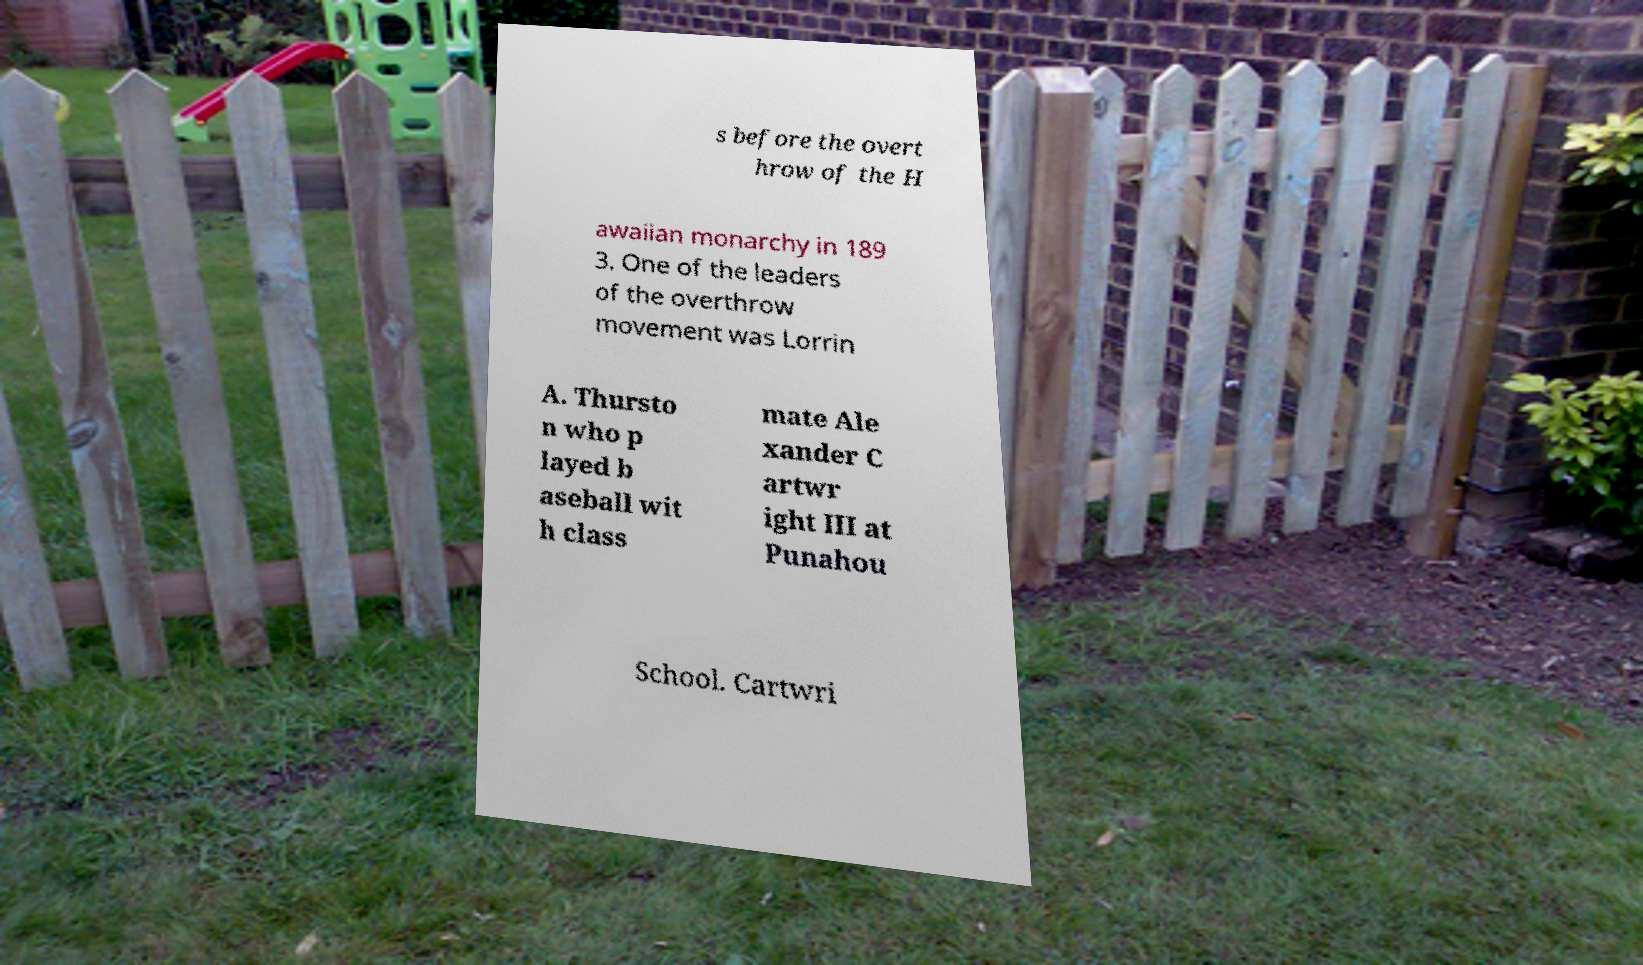Can you read and provide the text displayed in the image?This photo seems to have some interesting text. Can you extract and type it out for me? s before the overt hrow of the H awaiian monarchy in 189 3. One of the leaders of the overthrow movement was Lorrin A. Thursto n who p layed b aseball wit h class mate Ale xander C artwr ight III at Punahou School. Cartwri 